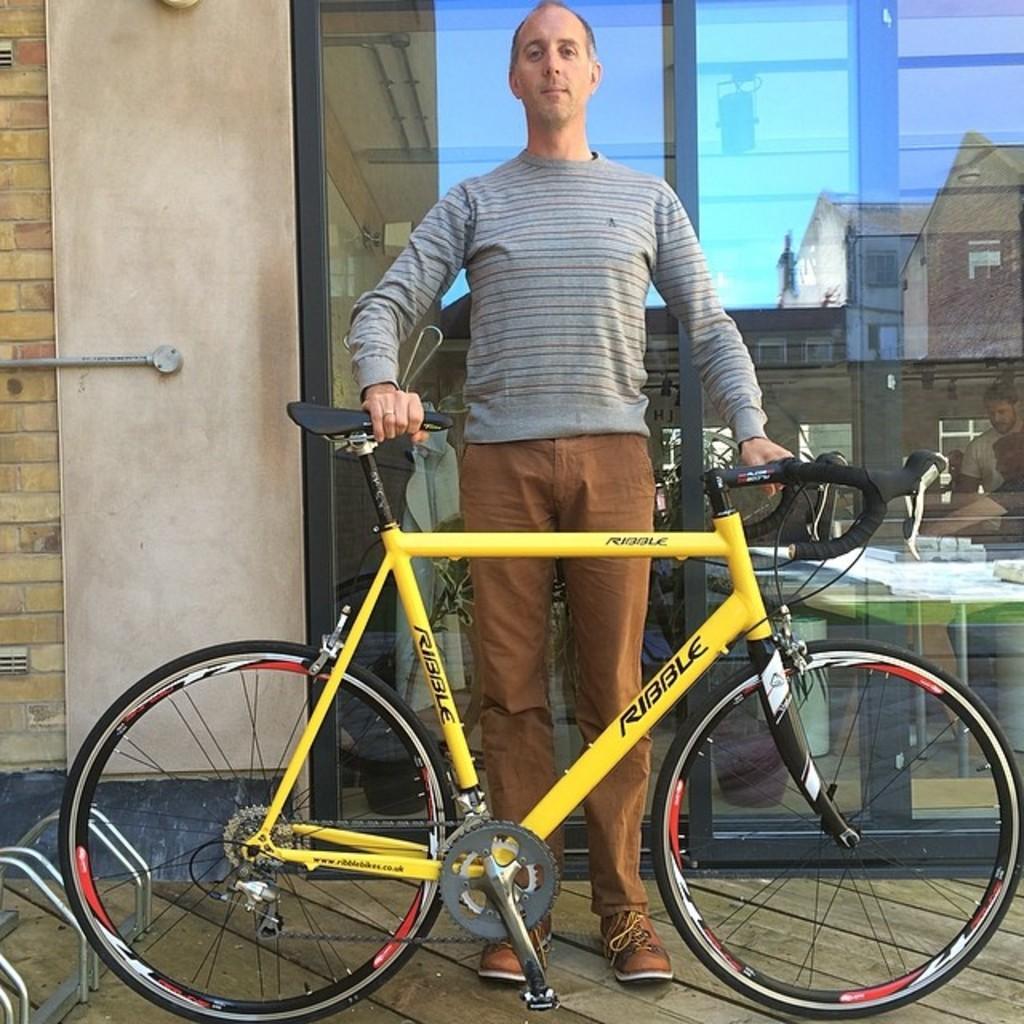Could you give a brief overview of what you see in this image? In this image, we can see a man holding a yellow color bicycle, in the background there is a glass door and there is a wall. 